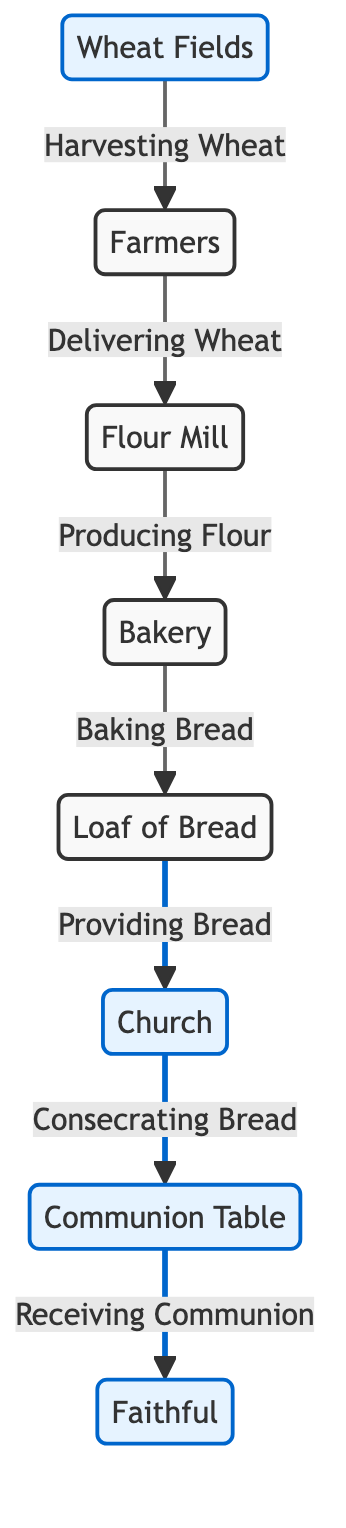What is the first node in the food chain? The first node in the food chain is the Wheat Fields, which represents where wheat is harvested.
Answer: Wheat Fields How many nodes are there in the diagram? To determine the number of nodes, we can count each of them: Wheat Fields, Farmers, Flour Mill, Bakery, Loaf of Bread, Church, Communion Table, and Faithful. This totals to 8 nodes.
Answer: 8 What connects Farmers to the Flour Mill? Farmers deliver wheat to the flour mill as indicated by the arrow and label in the diagram.
Answer: Delivering Wheat Which node comes after the Bakery? The node that comes directly after the Bakery represents the Loaf of Bread, signifying the product made in the bakery.
Answer: Loaf of Bread What is the last step before the Faithful receive communion? The last step is the consecration of the bread by the church before it is given to the faithful at the communion table.
Answer: Consecrating Bread How many connections lead into the Church node? The connections leading into the Church node are fewer than the output, and in this case, there is only one connection leading in, which is from the Bread node.
Answer: 1 Why is the Wheat Fields node categorized as special? The Wheat Fields node is categorized as special due to its significance in the food chain, acting as the source of wheat for the entire process.
Answer: Special What type of food chain does this diagram represent? This diagram illustrates a food chain specific to the journey of a loaf of bread, capturing various stages from raw material to religious practice.
Answer: Bread food chain 